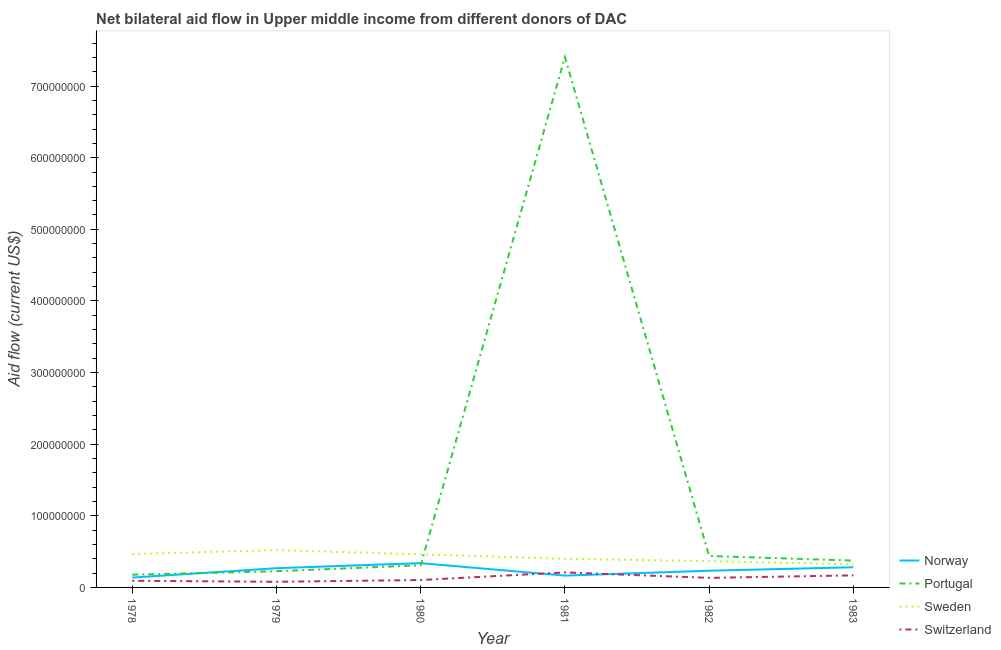How many different coloured lines are there?
Make the answer very short. 4. Does the line corresponding to amount of aid given by norway intersect with the line corresponding to amount of aid given by portugal?
Offer a terse response. Yes. What is the amount of aid given by norway in 1983?
Your response must be concise. 2.82e+07. Across all years, what is the maximum amount of aid given by norway?
Ensure brevity in your answer.  3.39e+07. Across all years, what is the minimum amount of aid given by sweden?
Your response must be concise. 3.22e+07. In which year was the amount of aid given by switzerland minimum?
Ensure brevity in your answer.  1979. What is the total amount of aid given by norway in the graph?
Offer a very short reply. 1.42e+08. What is the difference between the amount of aid given by norway in 1979 and that in 1980?
Offer a very short reply. -7.06e+06. What is the difference between the amount of aid given by switzerland in 1982 and the amount of aid given by norway in 1983?
Provide a short and direct response. -1.48e+07. What is the average amount of aid given by sweden per year?
Offer a terse response. 4.23e+07. In the year 1982, what is the difference between the amount of aid given by switzerland and amount of aid given by norway?
Your response must be concise. -9.96e+06. What is the ratio of the amount of aid given by switzerland in 1978 to that in 1982?
Provide a short and direct response. 0.7. Is the difference between the amount of aid given by portugal in 1980 and 1982 greater than the difference between the amount of aid given by sweden in 1980 and 1982?
Your response must be concise. No. What is the difference between the highest and the second highest amount of aid given by portugal?
Your response must be concise. 6.97e+08. What is the difference between the highest and the lowest amount of aid given by portugal?
Offer a very short reply. 7.23e+08. Is the sum of the amount of aid given by portugal in 1978 and 1980 greater than the maximum amount of aid given by sweden across all years?
Keep it short and to the point. No. Is it the case that in every year, the sum of the amount of aid given by norway and amount of aid given by portugal is greater than the amount of aid given by sweden?
Make the answer very short. No. How many lines are there?
Make the answer very short. 4. How many years are there in the graph?
Offer a terse response. 6. What is the difference between two consecutive major ticks on the Y-axis?
Provide a short and direct response. 1.00e+08. Are the values on the major ticks of Y-axis written in scientific E-notation?
Your response must be concise. No. Does the graph contain grids?
Ensure brevity in your answer.  No. Where does the legend appear in the graph?
Provide a succinct answer. Bottom right. How are the legend labels stacked?
Give a very brief answer. Vertical. What is the title of the graph?
Ensure brevity in your answer.  Net bilateral aid flow in Upper middle income from different donors of DAC. What is the Aid flow (current US$) in Norway in 1978?
Make the answer very short. 1.37e+07. What is the Aid flow (current US$) in Portugal in 1978?
Your answer should be compact. 1.78e+07. What is the Aid flow (current US$) in Sweden in 1978?
Provide a short and direct response. 4.66e+07. What is the Aid flow (current US$) in Switzerland in 1978?
Your response must be concise. 9.31e+06. What is the Aid flow (current US$) of Norway in 1979?
Provide a short and direct response. 2.68e+07. What is the Aid flow (current US$) in Portugal in 1979?
Give a very brief answer. 2.26e+07. What is the Aid flow (current US$) of Sweden in 1979?
Offer a terse response. 5.21e+07. What is the Aid flow (current US$) in Switzerland in 1979?
Make the answer very short. 7.86e+06. What is the Aid flow (current US$) in Norway in 1980?
Keep it short and to the point. 3.39e+07. What is the Aid flow (current US$) of Portugal in 1980?
Give a very brief answer. 3.10e+07. What is the Aid flow (current US$) in Sweden in 1980?
Offer a terse response. 4.62e+07. What is the Aid flow (current US$) of Switzerland in 1980?
Your answer should be compact. 1.03e+07. What is the Aid flow (current US$) in Norway in 1981?
Provide a short and direct response. 1.65e+07. What is the Aid flow (current US$) of Portugal in 1981?
Offer a very short reply. 7.41e+08. What is the Aid flow (current US$) of Sweden in 1981?
Your answer should be compact. 4.00e+07. What is the Aid flow (current US$) in Switzerland in 1981?
Your answer should be very brief. 2.10e+07. What is the Aid flow (current US$) in Norway in 1982?
Offer a very short reply. 2.33e+07. What is the Aid flow (current US$) in Portugal in 1982?
Offer a terse response. 4.39e+07. What is the Aid flow (current US$) of Sweden in 1982?
Keep it short and to the point. 3.67e+07. What is the Aid flow (current US$) in Switzerland in 1982?
Give a very brief answer. 1.34e+07. What is the Aid flow (current US$) of Norway in 1983?
Give a very brief answer. 2.82e+07. What is the Aid flow (current US$) in Portugal in 1983?
Offer a terse response. 3.75e+07. What is the Aid flow (current US$) of Sweden in 1983?
Provide a short and direct response. 3.22e+07. What is the Aid flow (current US$) of Switzerland in 1983?
Give a very brief answer. 1.68e+07. Across all years, what is the maximum Aid flow (current US$) of Norway?
Offer a very short reply. 3.39e+07. Across all years, what is the maximum Aid flow (current US$) of Portugal?
Provide a succinct answer. 7.41e+08. Across all years, what is the maximum Aid flow (current US$) in Sweden?
Your answer should be compact. 5.21e+07. Across all years, what is the maximum Aid flow (current US$) in Switzerland?
Keep it short and to the point. 2.10e+07. Across all years, what is the minimum Aid flow (current US$) of Norway?
Make the answer very short. 1.37e+07. Across all years, what is the minimum Aid flow (current US$) in Portugal?
Provide a short and direct response. 1.78e+07. Across all years, what is the minimum Aid flow (current US$) of Sweden?
Ensure brevity in your answer.  3.22e+07. Across all years, what is the minimum Aid flow (current US$) of Switzerland?
Offer a terse response. 7.86e+06. What is the total Aid flow (current US$) in Norway in the graph?
Your answer should be compact. 1.42e+08. What is the total Aid flow (current US$) in Portugal in the graph?
Give a very brief answer. 8.93e+08. What is the total Aid flow (current US$) of Sweden in the graph?
Your answer should be compact. 2.54e+08. What is the total Aid flow (current US$) in Switzerland in the graph?
Provide a succinct answer. 7.86e+07. What is the difference between the Aid flow (current US$) in Norway in 1978 and that in 1979?
Offer a very short reply. -1.31e+07. What is the difference between the Aid flow (current US$) of Portugal in 1978 and that in 1979?
Give a very brief answer. -4.81e+06. What is the difference between the Aid flow (current US$) in Sweden in 1978 and that in 1979?
Offer a very short reply. -5.56e+06. What is the difference between the Aid flow (current US$) of Switzerland in 1978 and that in 1979?
Your answer should be very brief. 1.45e+06. What is the difference between the Aid flow (current US$) in Norway in 1978 and that in 1980?
Give a very brief answer. -2.02e+07. What is the difference between the Aid flow (current US$) of Portugal in 1978 and that in 1980?
Make the answer very short. -1.32e+07. What is the difference between the Aid flow (current US$) of Switzerland in 1978 and that in 1980?
Keep it short and to the point. -1.02e+06. What is the difference between the Aid flow (current US$) in Norway in 1978 and that in 1981?
Make the answer very short. -2.76e+06. What is the difference between the Aid flow (current US$) in Portugal in 1978 and that in 1981?
Provide a short and direct response. -7.23e+08. What is the difference between the Aid flow (current US$) in Sweden in 1978 and that in 1981?
Ensure brevity in your answer.  6.57e+06. What is the difference between the Aid flow (current US$) in Switzerland in 1978 and that in 1981?
Your answer should be very brief. -1.16e+07. What is the difference between the Aid flow (current US$) in Norway in 1978 and that in 1982?
Make the answer very short. -9.58e+06. What is the difference between the Aid flow (current US$) of Portugal in 1978 and that in 1982?
Offer a very short reply. -2.62e+07. What is the difference between the Aid flow (current US$) in Sweden in 1978 and that in 1982?
Ensure brevity in your answer.  9.84e+06. What is the difference between the Aid flow (current US$) in Switzerland in 1978 and that in 1982?
Provide a succinct answer. -4.05e+06. What is the difference between the Aid flow (current US$) of Norway in 1978 and that in 1983?
Make the answer very short. -1.44e+07. What is the difference between the Aid flow (current US$) of Portugal in 1978 and that in 1983?
Offer a terse response. -1.97e+07. What is the difference between the Aid flow (current US$) in Sweden in 1978 and that in 1983?
Make the answer very short. 1.44e+07. What is the difference between the Aid flow (current US$) in Switzerland in 1978 and that in 1983?
Your answer should be very brief. -7.53e+06. What is the difference between the Aid flow (current US$) of Norway in 1979 and that in 1980?
Make the answer very short. -7.06e+06. What is the difference between the Aid flow (current US$) in Portugal in 1979 and that in 1980?
Your response must be concise. -8.38e+06. What is the difference between the Aid flow (current US$) in Sweden in 1979 and that in 1980?
Give a very brief answer. 5.92e+06. What is the difference between the Aid flow (current US$) of Switzerland in 1979 and that in 1980?
Your answer should be very brief. -2.47e+06. What is the difference between the Aid flow (current US$) in Norway in 1979 and that in 1981?
Give a very brief answer. 1.03e+07. What is the difference between the Aid flow (current US$) in Portugal in 1979 and that in 1981?
Your answer should be compact. -7.18e+08. What is the difference between the Aid flow (current US$) in Sweden in 1979 and that in 1981?
Your response must be concise. 1.21e+07. What is the difference between the Aid flow (current US$) in Switzerland in 1979 and that in 1981?
Provide a succinct answer. -1.31e+07. What is the difference between the Aid flow (current US$) of Norway in 1979 and that in 1982?
Offer a very short reply. 3.52e+06. What is the difference between the Aid flow (current US$) of Portugal in 1979 and that in 1982?
Make the answer very short. -2.13e+07. What is the difference between the Aid flow (current US$) in Sweden in 1979 and that in 1982?
Ensure brevity in your answer.  1.54e+07. What is the difference between the Aid flow (current US$) of Switzerland in 1979 and that in 1982?
Offer a terse response. -5.50e+06. What is the difference between the Aid flow (current US$) in Norway in 1979 and that in 1983?
Provide a succinct answer. -1.33e+06. What is the difference between the Aid flow (current US$) in Portugal in 1979 and that in 1983?
Your answer should be very brief. -1.49e+07. What is the difference between the Aid flow (current US$) in Sweden in 1979 and that in 1983?
Make the answer very short. 1.99e+07. What is the difference between the Aid flow (current US$) of Switzerland in 1979 and that in 1983?
Give a very brief answer. -8.98e+06. What is the difference between the Aid flow (current US$) in Norway in 1980 and that in 1981?
Give a very brief answer. 1.74e+07. What is the difference between the Aid flow (current US$) of Portugal in 1980 and that in 1981?
Your response must be concise. -7.10e+08. What is the difference between the Aid flow (current US$) of Sweden in 1980 and that in 1981?
Offer a terse response. 6.21e+06. What is the difference between the Aid flow (current US$) of Switzerland in 1980 and that in 1981?
Offer a terse response. -1.06e+07. What is the difference between the Aid flow (current US$) of Norway in 1980 and that in 1982?
Your answer should be compact. 1.06e+07. What is the difference between the Aid flow (current US$) in Portugal in 1980 and that in 1982?
Keep it short and to the point. -1.30e+07. What is the difference between the Aid flow (current US$) in Sweden in 1980 and that in 1982?
Provide a short and direct response. 9.48e+06. What is the difference between the Aid flow (current US$) of Switzerland in 1980 and that in 1982?
Make the answer very short. -3.03e+06. What is the difference between the Aid flow (current US$) in Norway in 1980 and that in 1983?
Your answer should be compact. 5.73e+06. What is the difference between the Aid flow (current US$) in Portugal in 1980 and that in 1983?
Your answer should be compact. -6.52e+06. What is the difference between the Aid flow (current US$) in Sweden in 1980 and that in 1983?
Your answer should be compact. 1.40e+07. What is the difference between the Aid flow (current US$) of Switzerland in 1980 and that in 1983?
Ensure brevity in your answer.  -6.51e+06. What is the difference between the Aid flow (current US$) of Norway in 1981 and that in 1982?
Ensure brevity in your answer.  -6.82e+06. What is the difference between the Aid flow (current US$) in Portugal in 1981 and that in 1982?
Offer a terse response. 6.97e+08. What is the difference between the Aid flow (current US$) in Sweden in 1981 and that in 1982?
Keep it short and to the point. 3.27e+06. What is the difference between the Aid flow (current US$) of Switzerland in 1981 and that in 1982?
Your response must be concise. 7.59e+06. What is the difference between the Aid flow (current US$) of Norway in 1981 and that in 1983?
Your response must be concise. -1.17e+07. What is the difference between the Aid flow (current US$) of Portugal in 1981 and that in 1983?
Your answer should be compact. 7.03e+08. What is the difference between the Aid flow (current US$) in Sweden in 1981 and that in 1983?
Give a very brief answer. 7.80e+06. What is the difference between the Aid flow (current US$) in Switzerland in 1981 and that in 1983?
Your answer should be very brief. 4.11e+06. What is the difference between the Aid flow (current US$) in Norway in 1982 and that in 1983?
Offer a terse response. -4.85e+06. What is the difference between the Aid flow (current US$) of Portugal in 1982 and that in 1983?
Ensure brevity in your answer.  6.44e+06. What is the difference between the Aid flow (current US$) in Sweden in 1982 and that in 1983?
Offer a very short reply. 4.53e+06. What is the difference between the Aid flow (current US$) in Switzerland in 1982 and that in 1983?
Provide a short and direct response. -3.48e+06. What is the difference between the Aid flow (current US$) in Norway in 1978 and the Aid flow (current US$) in Portugal in 1979?
Give a very brief answer. -8.83e+06. What is the difference between the Aid flow (current US$) in Norway in 1978 and the Aid flow (current US$) in Sweden in 1979?
Provide a short and direct response. -3.84e+07. What is the difference between the Aid flow (current US$) of Norway in 1978 and the Aid flow (current US$) of Switzerland in 1979?
Ensure brevity in your answer.  5.88e+06. What is the difference between the Aid flow (current US$) of Portugal in 1978 and the Aid flow (current US$) of Sweden in 1979?
Make the answer very short. -3.44e+07. What is the difference between the Aid flow (current US$) in Portugal in 1978 and the Aid flow (current US$) in Switzerland in 1979?
Give a very brief answer. 9.90e+06. What is the difference between the Aid flow (current US$) of Sweden in 1978 and the Aid flow (current US$) of Switzerland in 1979?
Your response must be concise. 3.87e+07. What is the difference between the Aid flow (current US$) of Norway in 1978 and the Aid flow (current US$) of Portugal in 1980?
Your response must be concise. -1.72e+07. What is the difference between the Aid flow (current US$) of Norway in 1978 and the Aid flow (current US$) of Sweden in 1980?
Offer a very short reply. -3.24e+07. What is the difference between the Aid flow (current US$) in Norway in 1978 and the Aid flow (current US$) in Switzerland in 1980?
Your answer should be very brief. 3.41e+06. What is the difference between the Aid flow (current US$) in Portugal in 1978 and the Aid flow (current US$) in Sweden in 1980?
Ensure brevity in your answer.  -2.84e+07. What is the difference between the Aid flow (current US$) in Portugal in 1978 and the Aid flow (current US$) in Switzerland in 1980?
Provide a short and direct response. 7.43e+06. What is the difference between the Aid flow (current US$) of Sweden in 1978 and the Aid flow (current US$) of Switzerland in 1980?
Provide a short and direct response. 3.62e+07. What is the difference between the Aid flow (current US$) in Norway in 1978 and the Aid flow (current US$) in Portugal in 1981?
Provide a short and direct response. -7.27e+08. What is the difference between the Aid flow (current US$) in Norway in 1978 and the Aid flow (current US$) in Sweden in 1981?
Your answer should be very brief. -2.62e+07. What is the difference between the Aid flow (current US$) in Norway in 1978 and the Aid flow (current US$) in Switzerland in 1981?
Your answer should be very brief. -7.21e+06. What is the difference between the Aid flow (current US$) in Portugal in 1978 and the Aid flow (current US$) in Sweden in 1981?
Give a very brief answer. -2.22e+07. What is the difference between the Aid flow (current US$) of Portugal in 1978 and the Aid flow (current US$) of Switzerland in 1981?
Your response must be concise. -3.19e+06. What is the difference between the Aid flow (current US$) in Sweden in 1978 and the Aid flow (current US$) in Switzerland in 1981?
Provide a short and direct response. 2.56e+07. What is the difference between the Aid flow (current US$) of Norway in 1978 and the Aid flow (current US$) of Portugal in 1982?
Your response must be concise. -3.02e+07. What is the difference between the Aid flow (current US$) of Norway in 1978 and the Aid flow (current US$) of Sweden in 1982?
Your answer should be very brief. -2.30e+07. What is the difference between the Aid flow (current US$) of Portugal in 1978 and the Aid flow (current US$) of Sweden in 1982?
Offer a very short reply. -1.90e+07. What is the difference between the Aid flow (current US$) of Portugal in 1978 and the Aid flow (current US$) of Switzerland in 1982?
Give a very brief answer. 4.40e+06. What is the difference between the Aid flow (current US$) of Sweden in 1978 and the Aid flow (current US$) of Switzerland in 1982?
Keep it short and to the point. 3.32e+07. What is the difference between the Aid flow (current US$) in Norway in 1978 and the Aid flow (current US$) in Portugal in 1983?
Offer a very short reply. -2.37e+07. What is the difference between the Aid flow (current US$) of Norway in 1978 and the Aid flow (current US$) of Sweden in 1983?
Offer a very short reply. -1.84e+07. What is the difference between the Aid flow (current US$) of Norway in 1978 and the Aid flow (current US$) of Switzerland in 1983?
Offer a terse response. -3.10e+06. What is the difference between the Aid flow (current US$) of Portugal in 1978 and the Aid flow (current US$) of Sweden in 1983?
Offer a very short reply. -1.44e+07. What is the difference between the Aid flow (current US$) in Portugal in 1978 and the Aid flow (current US$) in Switzerland in 1983?
Make the answer very short. 9.20e+05. What is the difference between the Aid flow (current US$) of Sweden in 1978 and the Aid flow (current US$) of Switzerland in 1983?
Offer a very short reply. 2.97e+07. What is the difference between the Aid flow (current US$) in Norway in 1979 and the Aid flow (current US$) in Portugal in 1980?
Provide a short and direct response. -4.11e+06. What is the difference between the Aid flow (current US$) in Norway in 1979 and the Aid flow (current US$) in Sweden in 1980?
Provide a short and direct response. -1.94e+07. What is the difference between the Aid flow (current US$) of Norway in 1979 and the Aid flow (current US$) of Switzerland in 1980?
Offer a very short reply. 1.65e+07. What is the difference between the Aid flow (current US$) of Portugal in 1979 and the Aid flow (current US$) of Sweden in 1980?
Your answer should be compact. -2.36e+07. What is the difference between the Aid flow (current US$) in Portugal in 1979 and the Aid flow (current US$) in Switzerland in 1980?
Keep it short and to the point. 1.22e+07. What is the difference between the Aid flow (current US$) in Sweden in 1979 and the Aid flow (current US$) in Switzerland in 1980?
Provide a succinct answer. 4.18e+07. What is the difference between the Aid flow (current US$) in Norway in 1979 and the Aid flow (current US$) in Portugal in 1981?
Provide a short and direct response. -7.14e+08. What is the difference between the Aid flow (current US$) of Norway in 1979 and the Aid flow (current US$) of Sweden in 1981?
Your response must be concise. -1.31e+07. What is the difference between the Aid flow (current US$) in Norway in 1979 and the Aid flow (current US$) in Switzerland in 1981?
Keep it short and to the point. 5.89e+06. What is the difference between the Aid flow (current US$) in Portugal in 1979 and the Aid flow (current US$) in Sweden in 1981?
Offer a very short reply. -1.74e+07. What is the difference between the Aid flow (current US$) in Portugal in 1979 and the Aid flow (current US$) in Switzerland in 1981?
Provide a short and direct response. 1.62e+06. What is the difference between the Aid flow (current US$) in Sweden in 1979 and the Aid flow (current US$) in Switzerland in 1981?
Offer a terse response. 3.12e+07. What is the difference between the Aid flow (current US$) in Norway in 1979 and the Aid flow (current US$) in Portugal in 1982?
Provide a short and direct response. -1.71e+07. What is the difference between the Aid flow (current US$) in Norway in 1979 and the Aid flow (current US$) in Sweden in 1982?
Offer a very short reply. -9.87e+06. What is the difference between the Aid flow (current US$) of Norway in 1979 and the Aid flow (current US$) of Switzerland in 1982?
Your response must be concise. 1.35e+07. What is the difference between the Aid flow (current US$) in Portugal in 1979 and the Aid flow (current US$) in Sweden in 1982?
Make the answer very short. -1.41e+07. What is the difference between the Aid flow (current US$) in Portugal in 1979 and the Aid flow (current US$) in Switzerland in 1982?
Your response must be concise. 9.21e+06. What is the difference between the Aid flow (current US$) in Sweden in 1979 and the Aid flow (current US$) in Switzerland in 1982?
Offer a terse response. 3.88e+07. What is the difference between the Aid flow (current US$) of Norway in 1979 and the Aid flow (current US$) of Portugal in 1983?
Make the answer very short. -1.06e+07. What is the difference between the Aid flow (current US$) of Norway in 1979 and the Aid flow (current US$) of Sweden in 1983?
Make the answer very short. -5.34e+06. What is the difference between the Aid flow (current US$) of Norway in 1979 and the Aid flow (current US$) of Switzerland in 1983?
Keep it short and to the point. 1.00e+07. What is the difference between the Aid flow (current US$) of Portugal in 1979 and the Aid flow (current US$) of Sweden in 1983?
Your response must be concise. -9.61e+06. What is the difference between the Aid flow (current US$) in Portugal in 1979 and the Aid flow (current US$) in Switzerland in 1983?
Give a very brief answer. 5.73e+06. What is the difference between the Aid flow (current US$) of Sweden in 1979 and the Aid flow (current US$) of Switzerland in 1983?
Provide a succinct answer. 3.53e+07. What is the difference between the Aid flow (current US$) in Norway in 1980 and the Aid flow (current US$) in Portugal in 1981?
Keep it short and to the point. -7.07e+08. What is the difference between the Aid flow (current US$) in Norway in 1980 and the Aid flow (current US$) in Sweden in 1981?
Offer a very short reply. -6.08e+06. What is the difference between the Aid flow (current US$) in Norway in 1980 and the Aid flow (current US$) in Switzerland in 1981?
Provide a short and direct response. 1.30e+07. What is the difference between the Aid flow (current US$) in Portugal in 1980 and the Aid flow (current US$) in Sweden in 1981?
Ensure brevity in your answer.  -9.03e+06. What is the difference between the Aid flow (current US$) in Portugal in 1980 and the Aid flow (current US$) in Switzerland in 1981?
Keep it short and to the point. 1.00e+07. What is the difference between the Aid flow (current US$) in Sweden in 1980 and the Aid flow (current US$) in Switzerland in 1981?
Provide a short and direct response. 2.52e+07. What is the difference between the Aid flow (current US$) of Norway in 1980 and the Aid flow (current US$) of Portugal in 1982?
Make the answer very short. -1.00e+07. What is the difference between the Aid flow (current US$) in Norway in 1980 and the Aid flow (current US$) in Sweden in 1982?
Provide a succinct answer. -2.81e+06. What is the difference between the Aid flow (current US$) of Norway in 1980 and the Aid flow (current US$) of Switzerland in 1982?
Ensure brevity in your answer.  2.05e+07. What is the difference between the Aid flow (current US$) of Portugal in 1980 and the Aid flow (current US$) of Sweden in 1982?
Give a very brief answer. -5.76e+06. What is the difference between the Aid flow (current US$) of Portugal in 1980 and the Aid flow (current US$) of Switzerland in 1982?
Provide a short and direct response. 1.76e+07. What is the difference between the Aid flow (current US$) in Sweden in 1980 and the Aid flow (current US$) in Switzerland in 1982?
Give a very brief answer. 3.28e+07. What is the difference between the Aid flow (current US$) of Norway in 1980 and the Aid flow (current US$) of Portugal in 1983?
Make the answer very short. -3.57e+06. What is the difference between the Aid flow (current US$) of Norway in 1980 and the Aid flow (current US$) of Sweden in 1983?
Offer a very short reply. 1.72e+06. What is the difference between the Aid flow (current US$) of Norway in 1980 and the Aid flow (current US$) of Switzerland in 1983?
Make the answer very short. 1.71e+07. What is the difference between the Aid flow (current US$) in Portugal in 1980 and the Aid flow (current US$) in Sweden in 1983?
Offer a very short reply. -1.23e+06. What is the difference between the Aid flow (current US$) in Portugal in 1980 and the Aid flow (current US$) in Switzerland in 1983?
Provide a short and direct response. 1.41e+07. What is the difference between the Aid flow (current US$) of Sweden in 1980 and the Aid flow (current US$) of Switzerland in 1983?
Your answer should be very brief. 2.94e+07. What is the difference between the Aid flow (current US$) of Norway in 1981 and the Aid flow (current US$) of Portugal in 1982?
Your answer should be compact. -2.74e+07. What is the difference between the Aid flow (current US$) in Norway in 1981 and the Aid flow (current US$) in Sweden in 1982?
Offer a very short reply. -2.02e+07. What is the difference between the Aid flow (current US$) in Norway in 1981 and the Aid flow (current US$) in Switzerland in 1982?
Provide a short and direct response. 3.14e+06. What is the difference between the Aid flow (current US$) in Portugal in 1981 and the Aid flow (current US$) in Sweden in 1982?
Offer a terse response. 7.04e+08. What is the difference between the Aid flow (current US$) in Portugal in 1981 and the Aid flow (current US$) in Switzerland in 1982?
Provide a succinct answer. 7.27e+08. What is the difference between the Aid flow (current US$) of Sweden in 1981 and the Aid flow (current US$) of Switzerland in 1982?
Provide a short and direct response. 2.66e+07. What is the difference between the Aid flow (current US$) in Norway in 1981 and the Aid flow (current US$) in Portugal in 1983?
Give a very brief answer. -2.10e+07. What is the difference between the Aid flow (current US$) in Norway in 1981 and the Aid flow (current US$) in Sweden in 1983?
Give a very brief answer. -1.57e+07. What is the difference between the Aid flow (current US$) of Portugal in 1981 and the Aid flow (current US$) of Sweden in 1983?
Ensure brevity in your answer.  7.08e+08. What is the difference between the Aid flow (current US$) of Portugal in 1981 and the Aid flow (current US$) of Switzerland in 1983?
Offer a very short reply. 7.24e+08. What is the difference between the Aid flow (current US$) in Sweden in 1981 and the Aid flow (current US$) in Switzerland in 1983?
Your response must be concise. 2.31e+07. What is the difference between the Aid flow (current US$) in Norway in 1982 and the Aid flow (current US$) in Portugal in 1983?
Provide a succinct answer. -1.42e+07. What is the difference between the Aid flow (current US$) in Norway in 1982 and the Aid flow (current US$) in Sweden in 1983?
Your answer should be compact. -8.86e+06. What is the difference between the Aid flow (current US$) in Norway in 1982 and the Aid flow (current US$) in Switzerland in 1983?
Provide a short and direct response. 6.48e+06. What is the difference between the Aid flow (current US$) of Portugal in 1982 and the Aid flow (current US$) of Sweden in 1983?
Make the answer very short. 1.17e+07. What is the difference between the Aid flow (current US$) of Portugal in 1982 and the Aid flow (current US$) of Switzerland in 1983?
Give a very brief answer. 2.71e+07. What is the difference between the Aid flow (current US$) of Sweden in 1982 and the Aid flow (current US$) of Switzerland in 1983?
Keep it short and to the point. 1.99e+07. What is the average Aid flow (current US$) of Norway per year?
Your answer should be compact. 2.37e+07. What is the average Aid flow (current US$) in Portugal per year?
Provide a short and direct response. 1.49e+08. What is the average Aid flow (current US$) in Sweden per year?
Offer a terse response. 4.23e+07. What is the average Aid flow (current US$) in Switzerland per year?
Keep it short and to the point. 1.31e+07. In the year 1978, what is the difference between the Aid flow (current US$) of Norway and Aid flow (current US$) of Portugal?
Provide a short and direct response. -4.02e+06. In the year 1978, what is the difference between the Aid flow (current US$) of Norway and Aid flow (current US$) of Sweden?
Offer a terse response. -3.28e+07. In the year 1978, what is the difference between the Aid flow (current US$) of Norway and Aid flow (current US$) of Switzerland?
Provide a succinct answer. 4.43e+06. In the year 1978, what is the difference between the Aid flow (current US$) of Portugal and Aid flow (current US$) of Sweden?
Ensure brevity in your answer.  -2.88e+07. In the year 1978, what is the difference between the Aid flow (current US$) of Portugal and Aid flow (current US$) of Switzerland?
Give a very brief answer. 8.45e+06. In the year 1978, what is the difference between the Aid flow (current US$) in Sweden and Aid flow (current US$) in Switzerland?
Provide a short and direct response. 3.72e+07. In the year 1979, what is the difference between the Aid flow (current US$) in Norway and Aid flow (current US$) in Portugal?
Your answer should be very brief. 4.27e+06. In the year 1979, what is the difference between the Aid flow (current US$) in Norway and Aid flow (current US$) in Sweden?
Offer a terse response. -2.53e+07. In the year 1979, what is the difference between the Aid flow (current US$) in Norway and Aid flow (current US$) in Switzerland?
Offer a terse response. 1.90e+07. In the year 1979, what is the difference between the Aid flow (current US$) of Portugal and Aid flow (current US$) of Sweden?
Your answer should be very brief. -2.95e+07. In the year 1979, what is the difference between the Aid flow (current US$) in Portugal and Aid flow (current US$) in Switzerland?
Give a very brief answer. 1.47e+07. In the year 1979, what is the difference between the Aid flow (current US$) of Sweden and Aid flow (current US$) of Switzerland?
Ensure brevity in your answer.  4.42e+07. In the year 1980, what is the difference between the Aid flow (current US$) of Norway and Aid flow (current US$) of Portugal?
Provide a succinct answer. 2.95e+06. In the year 1980, what is the difference between the Aid flow (current US$) of Norway and Aid flow (current US$) of Sweden?
Provide a succinct answer. -1.23e+07. In the year 1980, what is the difference between the Aid flow (current US$) of Norway and Aid flow (current US$) of Switzerland?
Your answer should be very brief. 2.36e+07. In the year 1980, what is the difference between the Aid flow (current US$) of Portugal and Aid flow (current US$) of Sweden?
Provide a succinct answer. -1.52e+07. In the year 1980, what is the difference between the Aid flow (current US$) in Portugal and Aid flow (current US$) in Switzerland?
Provide a short and direct response. 2.06e+07. In the year 1980, what is the difference between the Aid flow (current US$) of Sweden and Aid flow (current US$) of Switzerland?
Offer a terse response. 3.59e+07. In the year 1981, what is the difference between the Aid flow (current US$) in Norway and Aid flow (current US$) in Portugal?
Offer a terse response. -7.24e+08. In the year 1981, what is the difference between the Aid flow (current US$) in Norway and Aid flow (current US$) in Sweden?
Provide a short and direct response. -2.35e+07. In the year 1981, what is the difference between the Aid flow (current US$) of Norway and Aid flow (current US$) of Switzerland?
Make the answer very short. -4.45e+06. In the year 1981, what is the difference between the Aid flow (current US$) of Portugal and Aid flow (current US$) of Sweden?
Your response must be concise. 7.01e+08. In the year 1981, what is the difference between the Aid flow (current US$) of Portugal and Aid flow (current US$) of Switzerland?
Your answer should be very brief. 7.20e+08. In the year 1981, what is the difference between the Aid flow (current US$) in Sweden and Aid flow (current US$) in Switzerland?
Offer a terse response. 1.90e+07. In the year 1982, what is the difference between the Aid flow (current US$) of Norway and Aid flow (current US$) of Portugal?
Provide a succinct answer. -2.06e+07. In the year 1982, what is the difference between the Aid flow (current US$) in Norway and Aid flow (current US$) in Sweden?
Offer a terse response. -1.34e+07. In the year 1982, what is the difference between the Aid flow (current US$) of Norway and Aid flow (current US$) of Switzerland?
Provide a succinct answer. 9.96e+06. In the year 1982, what is the difference between the Aid flow (current US$) of Portugal and Aid flow (current US$) of Sweden?
Ensure brevity in your answer.  7.20e+06. In the year 1982, what is the difference between the Aid flow (current US$) of Portugal and Aid flow (current US$) of Switzerland?
Make the answer very short. 3.06e+07. In the year 1982, what is the difference between the Aid flow (current US$) of Sweden and Aid flow (current US$) of Switzerland?
Keep it short and to the point. 2.34e+07. In the year 1983, what is the difference between the Aid flow (current US$) of Norway and Aid flow (current US$) of Portugal?
Your answer should be compact. -9.30e+06. In the year 1983, what is the difference between the Aid flow (current US$) in Norway and Aid flow (current US$) in Sweden?
Your answer should be very brief. -4.01e+06. In the year 1983, what is the difference between the Aid flow (current US$) in Norway and Aid flow (current US$) in Switzerland?
Keep it short and to the point. 1.13e+07. In the year 1983, what is the difference between the Aid flow (current US$) in Portugal and Aid flow (current US$) in Sweden?
Your response must be concise. 5.29e+06. In the year 1983, what is the difference between the Aid flow (current US$) in Portugal and Aid flow (current US$) in Switzerland?
Your answer should be very brief. 2.06e+07. In the year 1983, what is the difference between the Aid flow (current US$) of Sweden and Aid flow (current US$) of Switzerland?
Provide a succinct answer. 1.53e+07. What is the ratio of the Aid flow (current US$) in Norway in 1978 to that in 1979?
Your answer should be very brief. 0.51. What is the ratio of the Aid flow (current US$) of Portugal in 1978 to that in 1979?
Your response must be concise. 0.79. What is the ratio of the Aid flow (current US$) of Sweden in 1978 to that in 1979?
Your answer should be compact. 0.89. What is the ratio of the Aid flow (current US$) of Switzerland in 1978 to that in 1979?
Ensure brevity in your answer.  1.18. What is the ratio of the Aid flow (current US$) of Norway in 1978 to that in 1980?
Your answer should be compact. 0.41. What is the ratio of the Aid flow (current US$) of Portugal in 1978 to that in 1980?
Your response must be concise. 0.57. What is the ratio of the Aid flow (current US$) in Switzerland in 1978 to that in 1980?
Offer a terse response. 0.9. What is the ratio of the Aid flow (current US$) of Norway in 1978 to that in 1981?
Ensure brevity in your answer.  0.83. What is the ratio of the Aid flow (current US$) in Portugal in 1978 to that in 1981?
Your response must be concise. 0.02. What is the ratio of the Aid flow (current US$) of Sweden in 1978 to that in 1981?
Offer a very short reply. 1.16. What is the ratio of the Aid flow (current US$) in Switzerland in 1978 to that in 1981?
Make the answer very short. 0.44. What is the ratio of the Aid flow (current US$) in Norway in 1978 to that in 1982?
Give a very brief answer. 0.59. What is the ratio of the Aid flow (current US$) of Portugal in 1978 to that in 1982?
Offer a terse response. 0.4. What is the ratio of the Aid flow (current US$) in Sweden in 1978 to that in 1982?
Provide a short and direct response. 1.27. What is the ratio of the Aid flow (current US$) of Switzerland in 1978 to that in 1982?
Provide a short and direct response. 0.7. What is the ratio of the Aid flow (current US$) of Norway in 1978 to that in 1983?
Provide a short and direct response. 0.49. What is the ratio of the Aid flow (current US$) in Portugal in 1978 to that in 1983?
Your answer should be very brief. 0.47. What is the ratio of the Aid flow (current US$) in Sweden in 1978 to that in 1983?
Your answer should be compact. 1.45. What is the ratio of the Aid flow (current US$) in Switzerland in 1978 to that in 1983?
Your response must be concise. 0.55. What is the ratio of the Aid flow (current US$) in Norway in 1979 to that in 1980?
Provide a short and direct response. 0.79. What is the ratio of the Aid flow (current US$) of Portugal in 1979 to that in 1980?
Your answer should be compact. 0.73. What is the ratio of the Aid flow (current US$) in Sweden in 1979 to that in 1980?
Offer a very short reply. 1.13. What is the ratio of the Aid flow (current US$) in Switzerland in 1979 to that in 1980?
Provide a short and direct response. 0.76. What is the ratio of the Aid flow (current US$) of Norway in 1979 to that in 1981?
Offer a terse response. 1.63. What is the ratio of the Aid flow (current US$) of Portugal in 1979 to that in 1981?
Keep it short and to the point. 0.03. What is the ratio of the Aid flow (current US$) in Sweden in 1979 to that in 1981?
Your answer should be very brief. 1.3. What is the ratio of the Aid flow (current US$) of Switzerland in 1979 to that in 1981?
Your answer should be very brief. 0.38. What is the ratio of the Aid flow (current US$) of Norway in 1979 to that in 1982?
Provide a succinct answer. 1.15. What is the ratio of the Aid flow (current US$) in Portugal in 1979 to that in 1982?
Your response must be concise. 0.51. What is the ratio of the Aid flow (current US$) of Sweden in 1979 to that in 1982?
Your answer should be compact. 1.42. What is the ratio of the Aid flow (current US$) of Switzerland in 1979 to that in 1982?
Give a very brief answer. 0.59. What is the ratio of the Aid flow (current US$) of Norway in 1979 to that in 1983?
Offer a very short reply. 0.95. What is the ratio of the Aid flow (current US$) of Portugal in 1979 to that in 1983?
Your answer should be compact. 0.6. What is the ratio of the Aid flow (current US$) of Sweden in 1979 to that in 1983?
Your answer should be compact. 1.62. What is the ratio of the Aid flow (current US$) of Switzerland in 1979 to that in 1983?
Provide a succinct answer. 0.47. What is the ratio of the Aid flow (current US$) in Norway in 1980 to that in 1981?
Your response must be concise. 2.05. What is the ratio of the Aid flow (current US$) in Portugal in 1980 to that in 1981?
Your answer should be compact. 0.04. What is the ratio of the Aid flow (current US$) in Sweden in 1980 to that in 1981?
Make the answer very short. 1.16. What is the ratio of the Aid flow (current US$) of Switzerland in 1980 to that in 1981?
Make the answer very short. 0.49. What is the ratio of the Aid flow (current US$) in Norway in 1980 to that in 1982?
Your answer should be compact. 1.45. What is the ratio of the Aid flow (current US$) of Portugal in 1980 to that in 1982?
Make the answer very short. 0.7. What is the ratio of the Aid flow (current US$) of Sweden in 1980 to that in 1982?
Your answer should be compact. 1.26. What is the ratio of the Aid flow (current US$) of Switzerland in 1980 to that in 1982?
Keep it short and to the point. 0.77. What is the ratio of the Aid flow (current US$) of Norway in 1980 to that in 1983?
Keep it short and to the point. 1.2. What is the ratio of the Aid flow (current US$) in Portugal in 1980 to that in 1983?
Your answer should be compact. 0.83. What is the ratio of the Aid flow (current US$) in Sweden in 1980 to that in 1983?
Make the answer very short. 1.44. What is the ratio of the Aid flow (current US$) in Switzerland in 1980 to that in 1983?
Provide a short and direct response. 0.61. What is the ratio of the Aid flow (current US$) in Norway in 1981 to that in 1982?
Offer a terse response. 0.71. What is the ratio of the Aid flow (current US$) in Portugal in 1981 to that in 1982?
Offer a terse response. 16.86. What is the ratio of the Aid flow (current US$) in Sweden in 1981 to that in 1982?
Make the answer very short. 1.09. What is the ratio of the Aid flow (current US$) in Switzerland in 1981 to that in 1982?
Make the answer very short. 1.57. What is the ratio of the Aid flow (current US$) in Norway in 1981 to that in 1983?
Your answer should be compact. 0.59. What is the ratio of the Aid flow (current US$) in Portugal in 1981 to that in 1983?
Make the answer very short. 19.76. What is the ratio of the Aid flow (current US$) in Sweden in 1981 to that in 1983?
Ensure brevity in your answer.  1.24. What is the ratio of the Aid flow (current US$) in Switzerland in 1981 to that in 1983?
Provide a short and direct response. 1.24. What is the ratio of the Aid flow (current US$) of Norway in 1982 to that in 1983?
Give a very brief answer. 0.83. What is the ratio of the Aid flow (current US$) of Portugal in 1982 to that in 1983?
Make the answer very short. 1.17. What is the ratio of the Aid flow (current US$) in Sweden in 1982 to that in 1983?
Ensure brevity in your answer.  1.14. What is the ratio of the Aid flow (current US$) in Switzerland in 1982 to that in 1983?
Give a very brief answer. 0.79. What is the difference between the highest and the second highest Aid flow (current US$) of Norway?
Offer a terse response. 5.73e+06. What is the difference between the highest and the second highest Aid flow (current US$) in Portugal?
Your answer should be compact. 6.97e+08. What is the difference between the highest and the second highest Aid flow (current US$) in Sweden?
Provide a short and direct response. 5.56e+06. What is the difference between the highest and the second highest Aid flow (current US$) of Switzerland?
Your answer should be compact. 4.11e+06. What is the difference between the highest and the lowest Aid flow (current US$) in Norway?
Provide a short and direct response. 2.02e+07. What is the difference between the highest and the lowest Aid flow (current US$) of Portugal?
Provide a succinct answer. 7.23e+08. What is the difference between the highest and the lowest Aid flow (current US$) in Sweden?
Provide a short and direct response. 1.99e+07. What is the difference between the highest and the lowest Aid flow (current US$) in Switzerland?
Your answer should be very brief. 1.31e+07. 